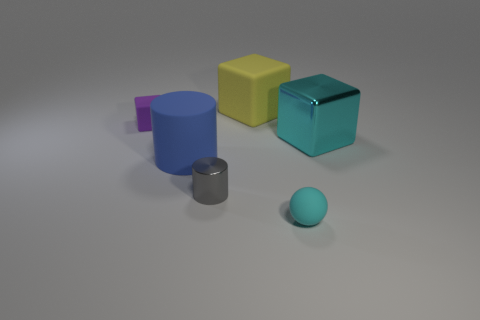Which objects in the image could logically be stacked on top of one another based on their shapes and sizes? Based on their shapes and sizes, the small rubber ball could be placed on top of either the yellow cube or the cyan cube without rolling off, considering they have flat surfaces. Similarly, the small metal cylinder could be placed on top of any of the cubes for the same reason. Stacking any objects on the cylinder or the rubber ball would be less stable due to their curved surfaces. 